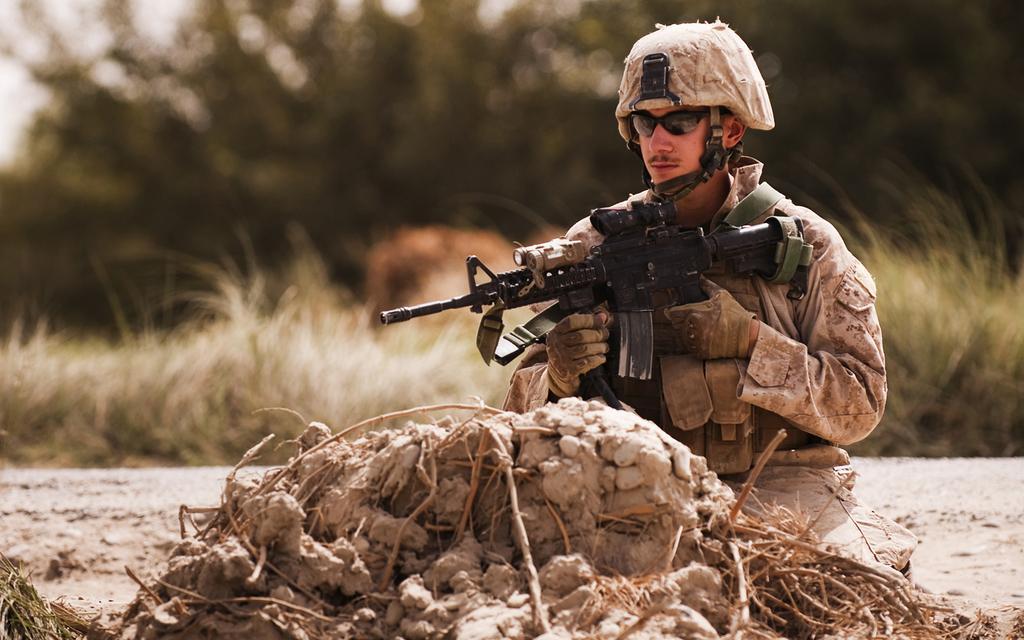In one or two sentences, can you explain what this image depicts? This picture is clicked outside the city. In the foreground we can see the stones and dry stems. In the center there is a man wearing uniform, holding a rifle and seems to be sitting on the ground. In the background we can see the trees and the plants. 